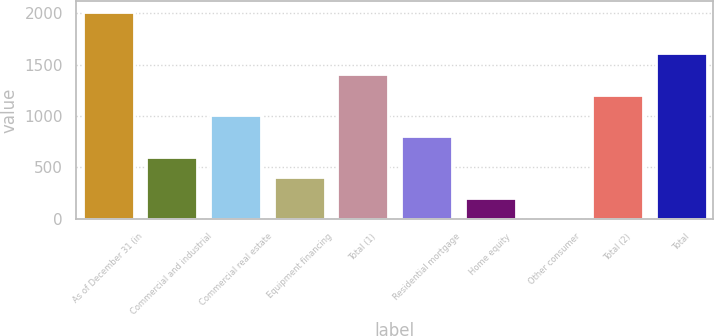Convert chart. <chart><loc_0><loc_0><loc_500><loc_500><bar_chart><fcel>As of December 31 (in<fcel>Commercial and industrial<fcel>Commercial real estate<fcel>Equipment financing<fcel>Total (1)<fcel>Residential mortgage<fcel>Home equity<fcel>Other consumer<fcel>Total (2)<fcel>Total<nl><fcel>2013<fcel>603.97<fcel>1006.55<fcel>402.68<fcel>1409.13<fcel>805.26<fcel>201.39<fcel>0.1<fcel>1207.84<fcel>1610.42<nl></chart> 